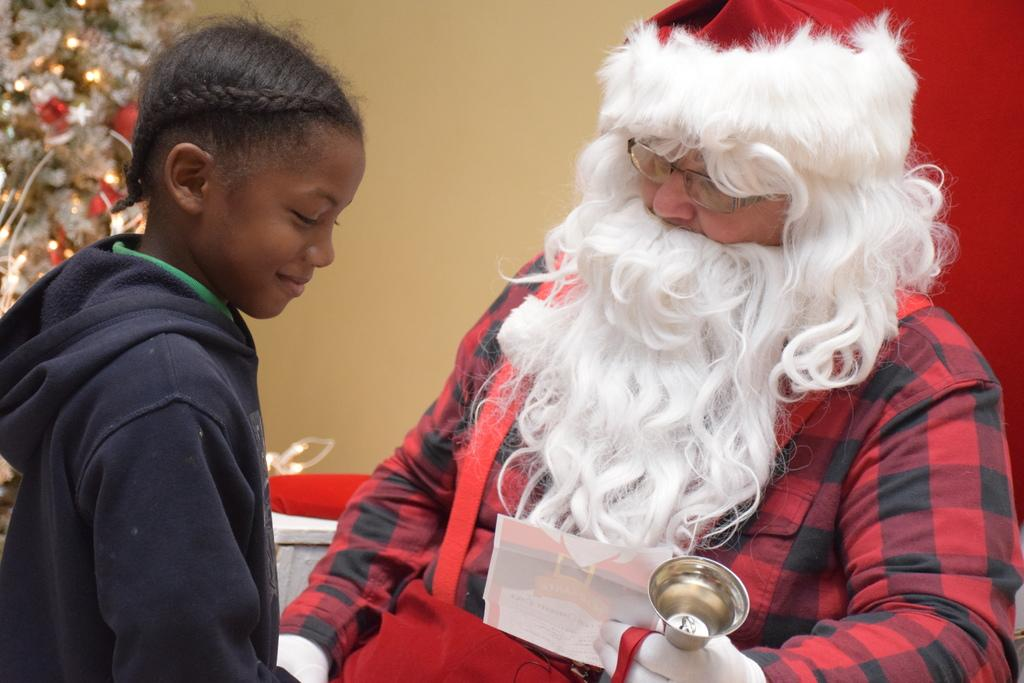What is the person in the image wearing on their head? The person in the image is wearing a white and red cap. What can be observed about the person's facial hair? The person has a white mustache. How many people are in the image? There are two people in the image. What is present in the image besides the people? There is a tree in the image. How is the tree decorated? The tree is decorated with lights and other things. What type of organization is the person in the image a part of? There is no information in the image about any organization the person might be a part of. Can you tell me how many hydrants are visible in the image? There are no hydrants present in the image. 